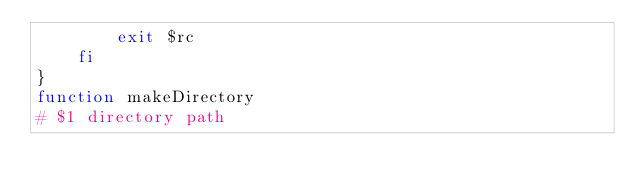<code> <loc_0><loc_0><loc_500><loc_500><_Bash_>        exit $rc
    fi
}
function makeDirectory
# $1 directory path</code> 